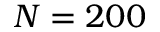Convert formula to latex. <formula><loc_0><loc_0><loc_500><loc_500>N = 2 0 0</formula> 